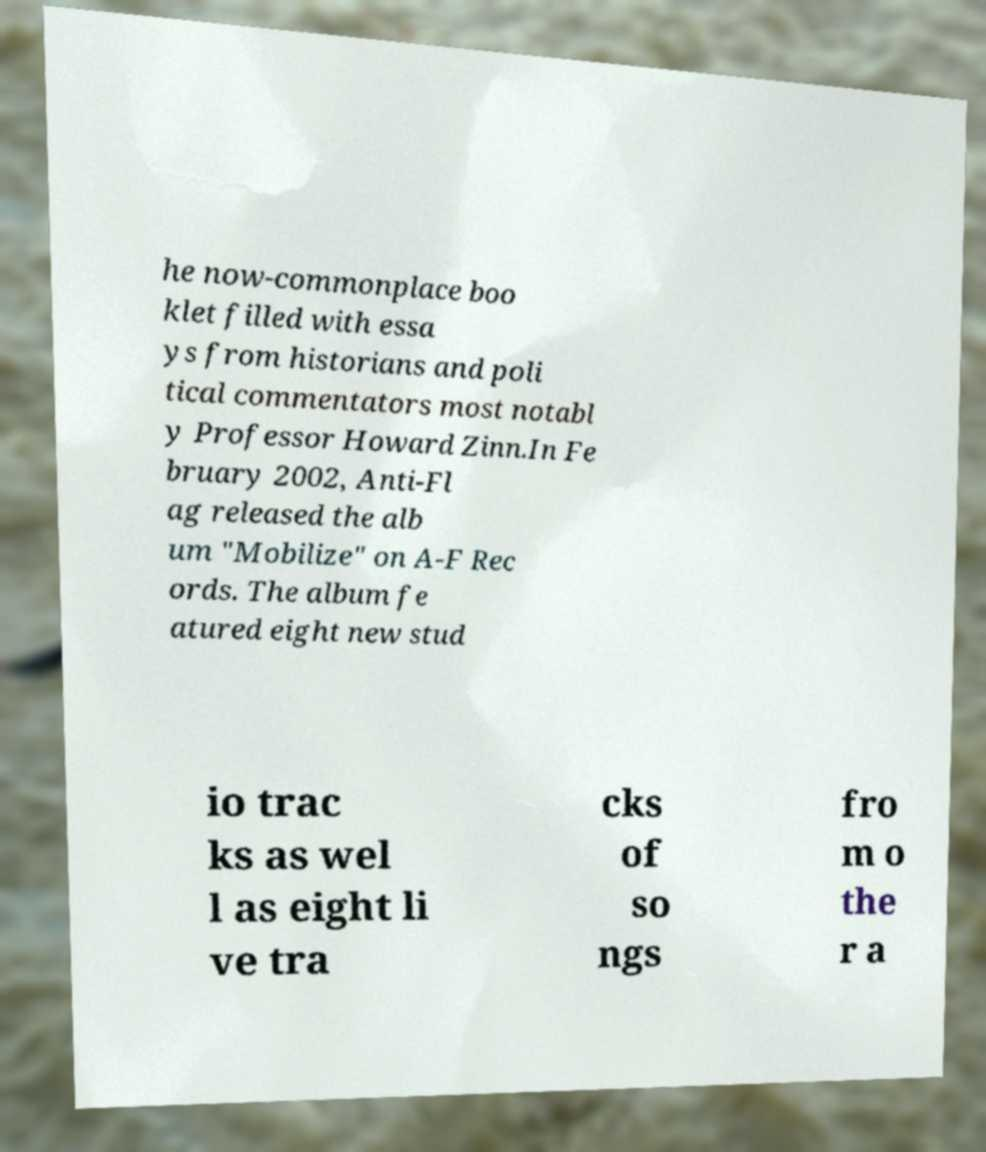Can you read and provide the text displayed in the image?This photo seems to have some interesting text. Can you extract and type it out for me? he now-commonplace boo klet filled with essa ys from historians and poli tical commentators most notabl y Professor Howard Zinn.In Fe bruary 2002, Anti-Fl ag released the alb um "Mobilize" on A-F Rec ords. The album fe atured eight new stud io trac ks as wel l as eight li ve tra cks of so ngs fro m o the r a 